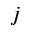<formula> <loc_0><loc_0><loc_500><loc_500>j</formula> 